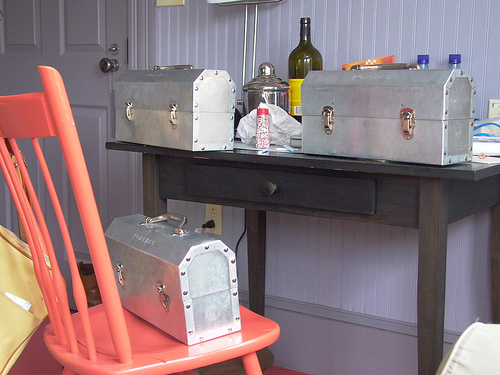<image>
Can you confirm if the toolbox is on the table? No. The toolbox is not positioned on the table. They may be near each other, but the toolbox is not supported by or resting on top of the table. Is the toolbox on the chair? No. The toolbox is not positioned on the chair. They may be near each other, but the toolbox is not supported by or resting on top of the chair. 